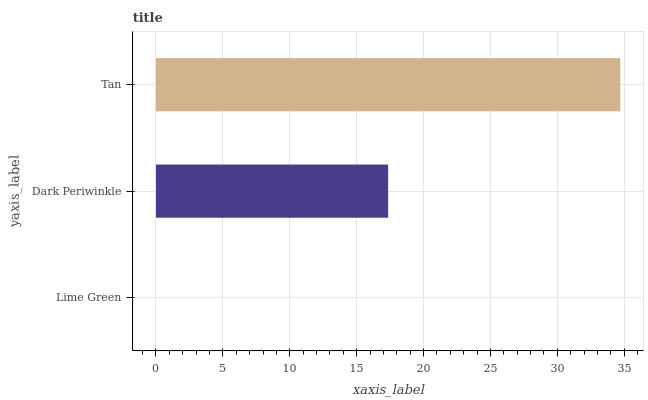Is Lime Green the minimum?
Answer yes or no. Yes. Is Tan the maximum?
Answer yes or no. Yes. Is Dark Periwinkle the minimum?
Answer yes or no. No. Is Dark Periwinkle the maximum?
Answer yes or no. No. Is Dark Periwinkle greater than Lime Green?
Answer yes or no. Yes. Is Lime Green less than Dark Periwinkle?
Answer yes or no. Yes. Is Lime Green greater than Dark Periwinkle?
Answer yes or no. No. Is Dark Periwinkle less than Lime Green?
Answer yes or no. No. Is Dark Periwinkle the high median?
Answer yes or no. Yes. Is Dark Periwinkle the low median?
Answer yes or no. Yes. Is Tan the high median?
Answer yes or no. No. Is Tan the low median?
Answer yes or no. No. 